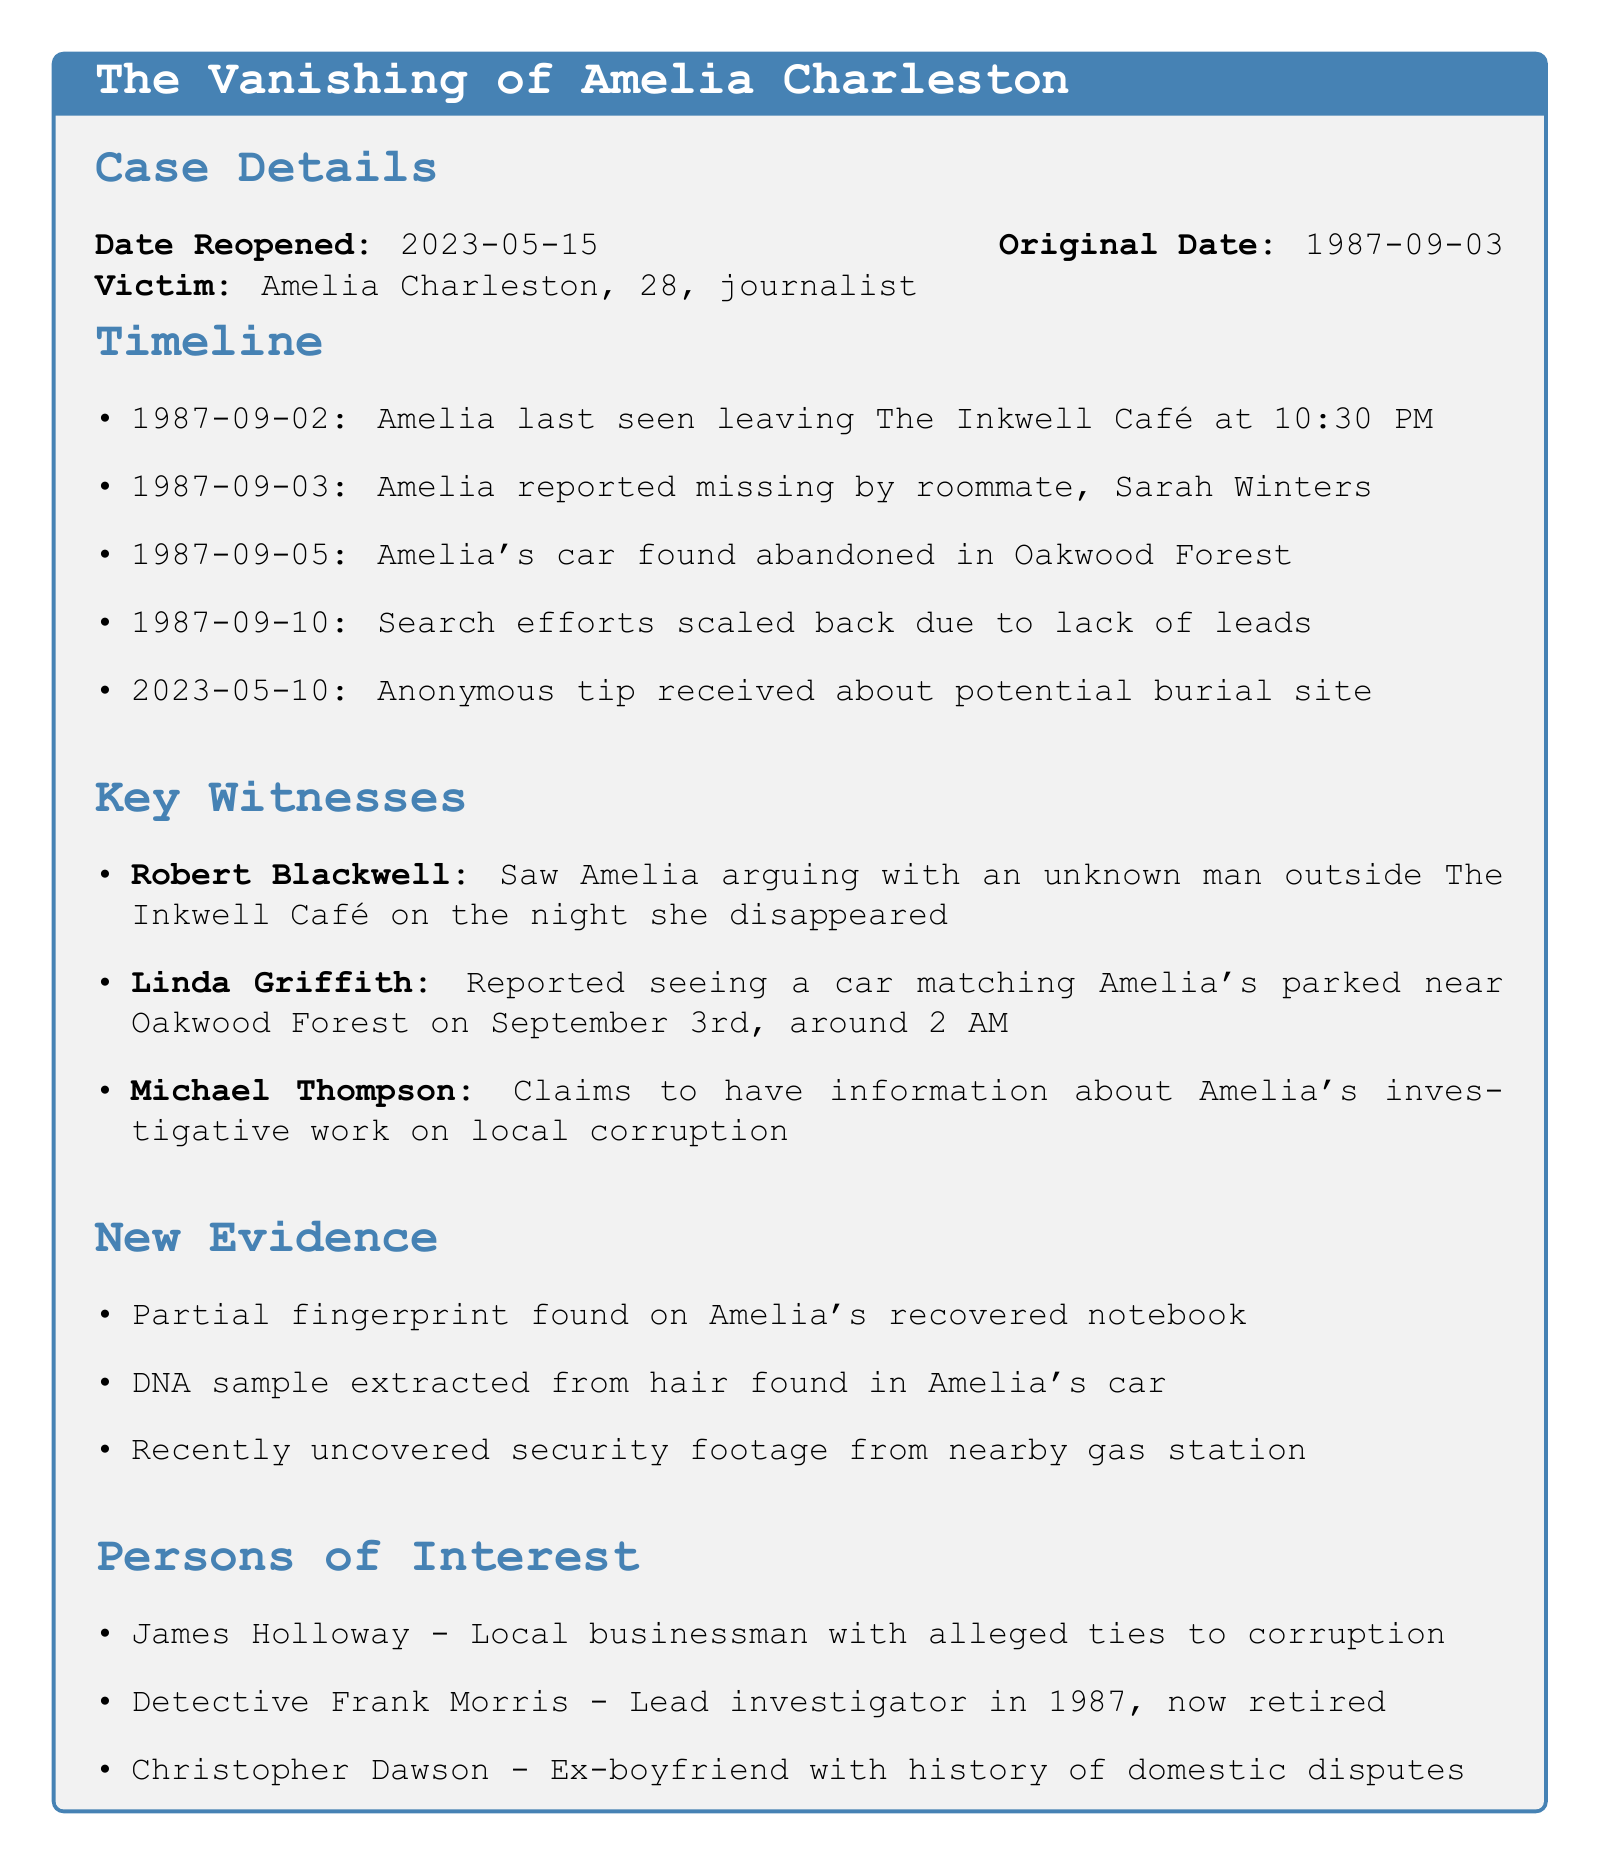What is the original date of the case? The original date is stated in the case details section of the document.
Answer: 1987-09-03 Who reported Amelia missing? The statement about who reported Amelia missing is found in the timeline section of the document.
Answer: Sarah Winters What was found on September 5, 1987? The event on this date is detailed in the timeline section, highlighting an important discovery.
Answer: Amelia's car found abandoned in Oakwood Forest How many key witnesses are mentioned? This question requires counting the listed key witnesses in the document.
Answer: 3 What evidence was recently uncovered? The new evidence section highlights recent findings that are significant to the case.
Answer: Recently uncovered security footage from nearby gas station Which person of interest has a history of domestic disputes? The persons of interest section includes details on individuals and their backgrounds related to the case.
Answer: Christopher Dawson What event caused search efforts to scale back? This question summarizes an important development in the timeline regarding the lack of leads.
Answer: Lack of leads What is the date when the case was reopened? The reopening date is specified in the case details section of the document.
Answer: 2023-05-15 